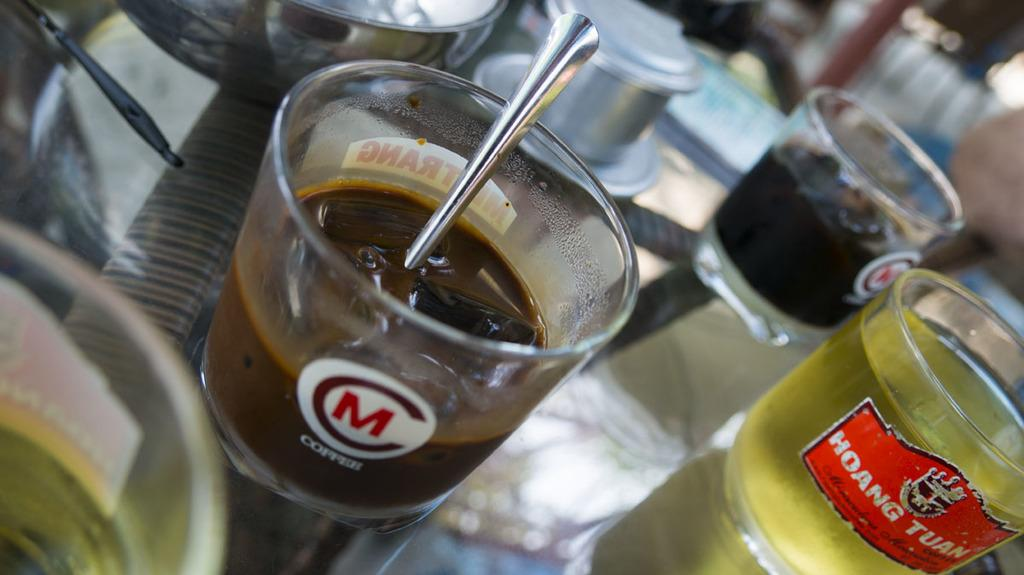<image>
Summarize the visual content of the image. The word copper is on a glass with other glasses surrounding it. 